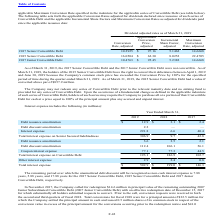According to Microchip Technology's financial document, What was the remaining period over which the unamortized debt discount will be recognized as non-cash interest expense for the 2017 Senior Convertible Debt? According to the financial document, 7.88 years. The relevant text states: "years, 5.88 years, and 17.88 years for the 2017 Senior Convertible Debt, 2015 Senior Convertible Debt and 2017 Junior Convertible Debt,..." Also, What was the Debt issuance amortization in 2018? According to the financial document, 3.1 (in millions). The relevant text states: "Debt issuance amortization $ 12.9 $ 3.1 $ 2.4..." Also, Which years does the table provide information for the company's interest expense? The document contains multiple relevant values: 2019, 2018, 2017. From the document: "2019 2018 2017 2019 2018 2017 2019 2018 2017..." Also, can you calculate: What was the change in Other interest expense between 2017 and 2018? Based on the calculation: 2.4-0.8, the result is 1.6 (in millions). This is based on the information: "Other interest expense 2.9 2.4 0.8 Other interest expense 2.9 2.4 0.8..." The key data points involved are: 0.8, 2.4. Also, How many years did Debt discount amortization exceed $100 million? Counting the relevant items in the document: 2019, 2018, I find 2 instances. The key data points involved are: 2018, 2019. Also, can you calculate: What was the percentage change in total interest expense between 2018 and 2019? To answer this question, I need to perform calculations using the financial data. The calculation is: (502.9-199.0)/199.0, which equals 152.71 (percentage). This is based on the information: "Total interest expense $ 502.9 $ 199.0 $ 146.3 Total interest expense $ 502.9 $ 199.0 $ 146.3..." The key data points involved are: 199.0, 502.9. 